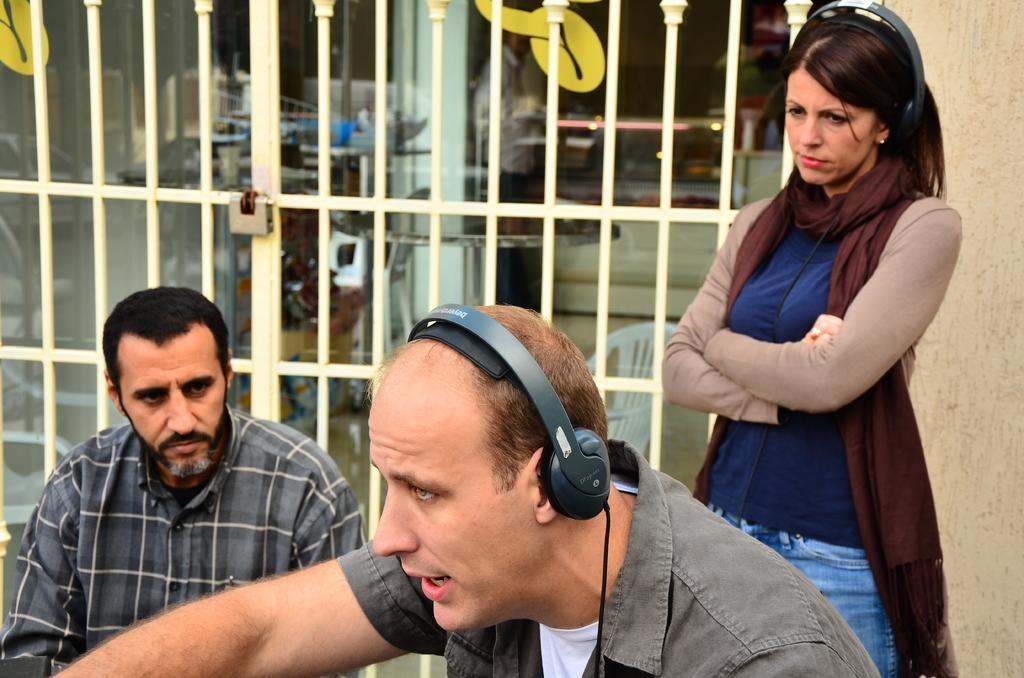How would you summarize this image in a sentence or two? In this image there are few people, in them two are wearing the headset on their heads, behind them there is a gate and a fencing wall of a building. 